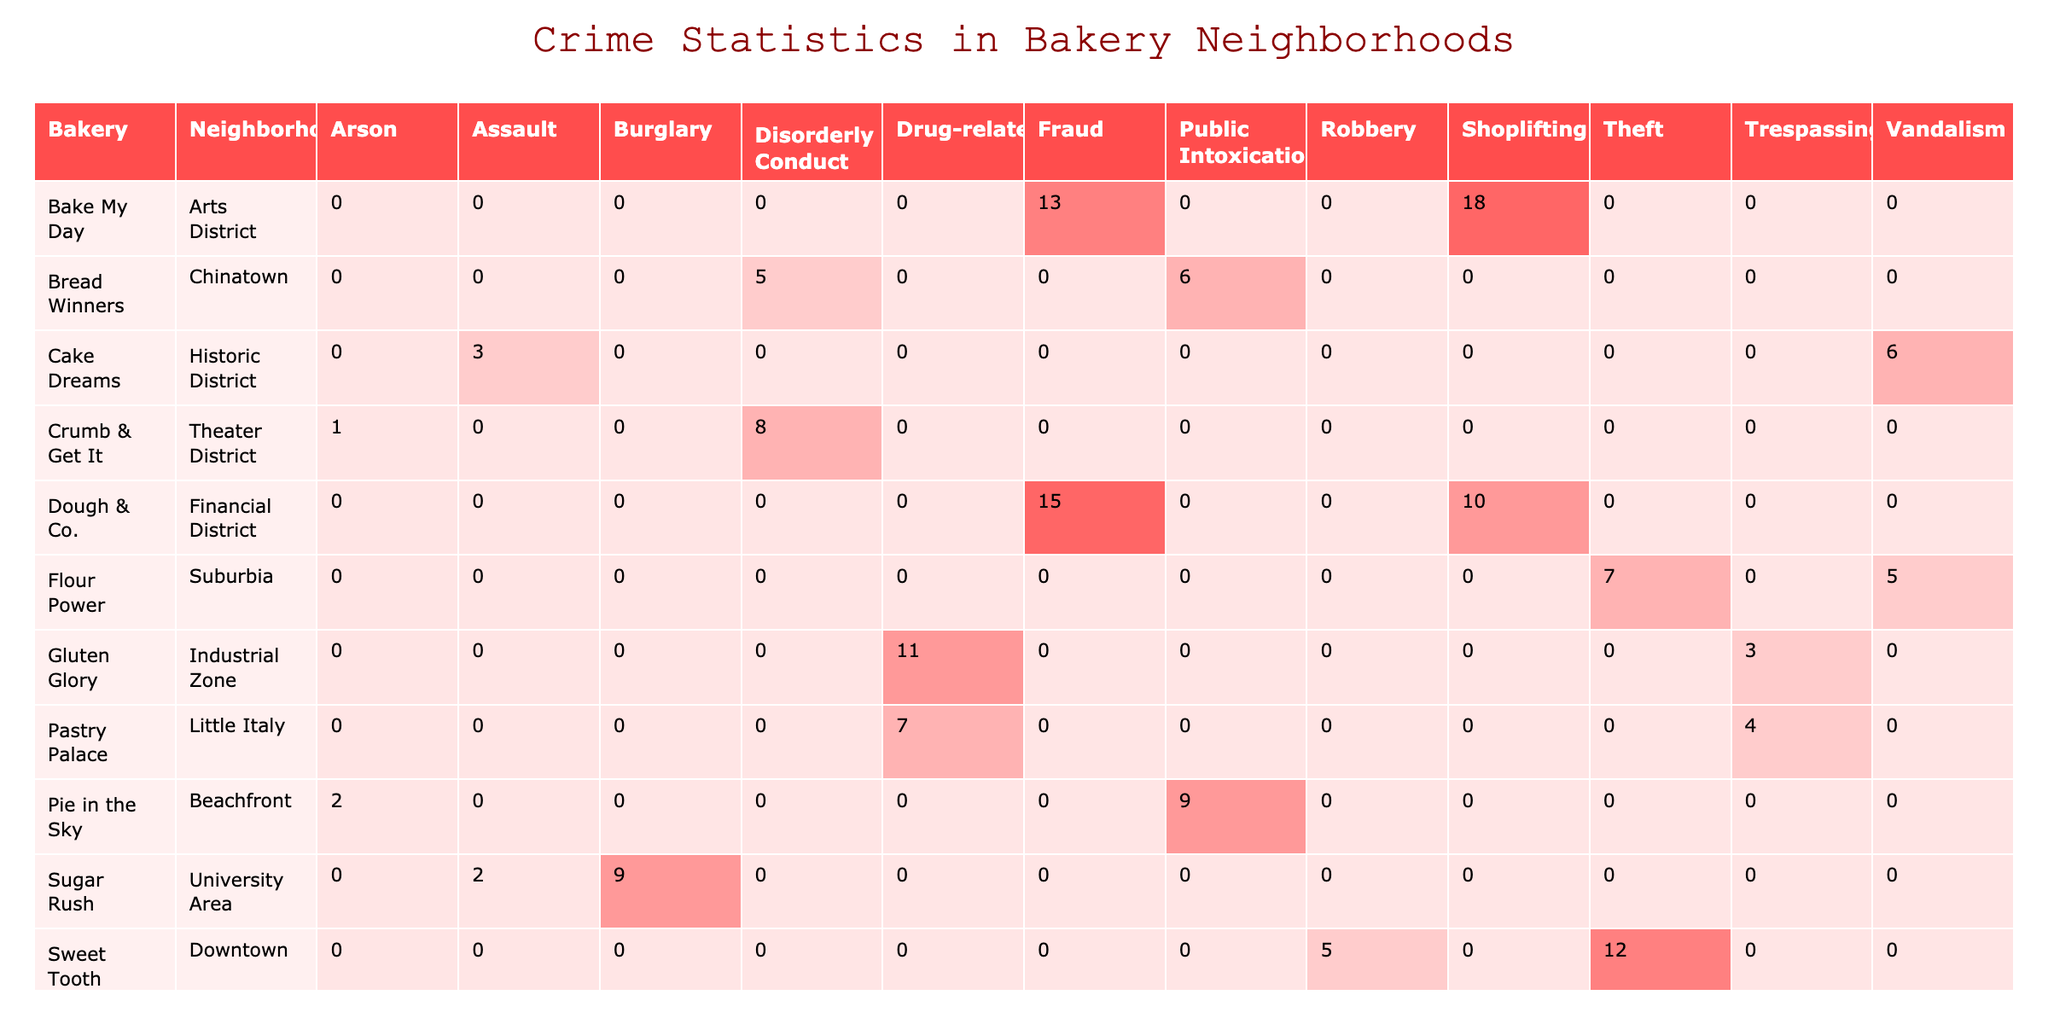What bakery has the highest number of incidents related to theft? In the table, we look for the column labeled "Theft" and compare the values. Sweet Tooth Bakery shows 12 incidents, while Flour Power has 7. Therefore, Sweet Tooth Bakery has the highest theft incidents.
Answer: Sweet Tooth Bakery Which neighborhood has the least number of incidents for assault? To find this, we check the "Assault" column for each bakery. Sugar Rush has 2 incidents in University Area while Cake Dreams has 3 in Historic District. Thus, University Area has the least incidents for assault.
Answer: University Area What is the total number of robbery incidents across all neighborhoods? We sum up the robbery incidents from the "Robbery" column for each bakery: The Crusty Loaf has 7, and Sweet Tooth Bakery has 5. Adding these gives us 7 + 5 = 12.
Answer: 12 Is there any bakery in the Arts District that has incidents related to drug-related crimes? Looking at the "Arts District" row, Bake My Day has incidents related to fraud and shoplifting, while Pastry Palace does not list any drug-related incidents. So there are no such incidents.
Answer: No Which bakery has the highest total number of incidents and what is that number? We need to sum the incidents for each bakery: Sweet Tooth Bakery (12+5=17), Flour Power (5+7=12), and so on. After summing, we find Sweet Tooth Bakery with 17 incidents has the highest total.
Answer: Sweet Tooth Bakery, 17 What percentage of incidents for burglary comes from Sugar Rush? Sugar Rush had 9 incidents of burglary, and the total burglaries from the table is 9 (Sugar Rush) + 4 (The Crusty Loaf) = 13. The percentage is calculated as (9/13)*100 ≈ 69.23%.
Answer: Approximately 69.23% Are there any neighborhoods listed that experienced the crime type Arson? The table includes the "Arson" incidents, which shows Pie in the Sky in the Beachfront neighborhood with 2 incidents, and Crumb & Get It in the Theater District with 1 incident. Thus, both neighborhoods experienced arson.
Answer: Yes What is the average number of incidents for shoplifting across all bakeries? The number of incidents for shoplifting includes Dough & Co (10) and Bake My Day (18), giving a total of 10 + 18 = 28 incidents. With 2 data points, the average is 28/2 = 14.
Answer: 14 